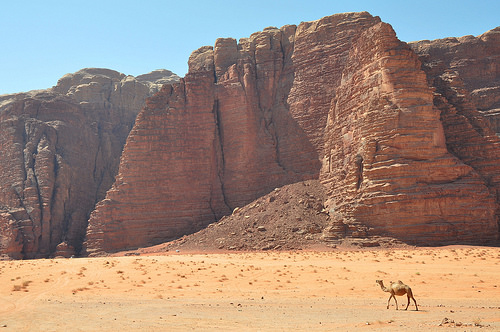<image>
Can you confirm if the camel is in the desert? Yes. The camel is contained within or inside the desert, showing a containment relationship. 